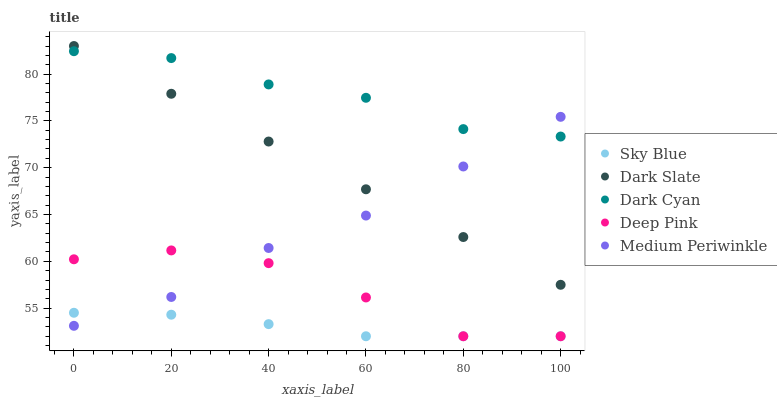Does Sky Blue have the minimum area under the curve?
Answer yes or no. Yes. Does Dark Cyan have the maximum area under the curve?
Answer yes or no. Yes. Does Deep Pink have the minimum area under the curve?
Answer yes or no. No. Does Deep Pink have the maximum area under the curve?
Answer yes or no. No. Is Dark Slate the smoothest?
Answer yes or no. Yes. Is Deep Pink the roughest?
Answer yes or no. Yes. Is Sky Blue the smoothest?
Answer yes or no. No. Is Sky Blue the roughest?
Answer yes or no. No. Does Sky Blue have the lowest value?
Answer yes or no. Yes. Does Medium Periwinkle have the lowest value?
Answer yes or no. No. Does Dark Slate have the highest value?
Answer yes or no. Yes. Does Deep Pink have the highest value?
Answer yes or no. No. Is Deep Pink less than Dark Slate?
Answer yes or no. Yes. Is Dark Slate greater than Deep Pink?
Answer yes or no. Yes. Does Deep Pink intersect Sky Blue?
Answer yes or no. Yes. Is Deep Pink less than Sky Blue?
Answer yes or no. No. Is Deep Pink greater than Sky Blue?
Answer yes or no. No. Does Deep Pink intersect Dark Slate?
Answer yes or no. No. 